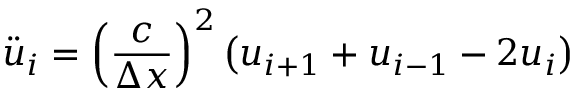Convert formula to latex. <formula><loc_0><loc_0><loc_500><loc_500>{ \ddot { u } } _ { i } = { \left ( { \frac { c } { \Delta x } } \right ) } ^ { 2 } \left ( u _ { i + 1 } + u _ { i - 1 } - 2 u _ { i } \right )</formula> 